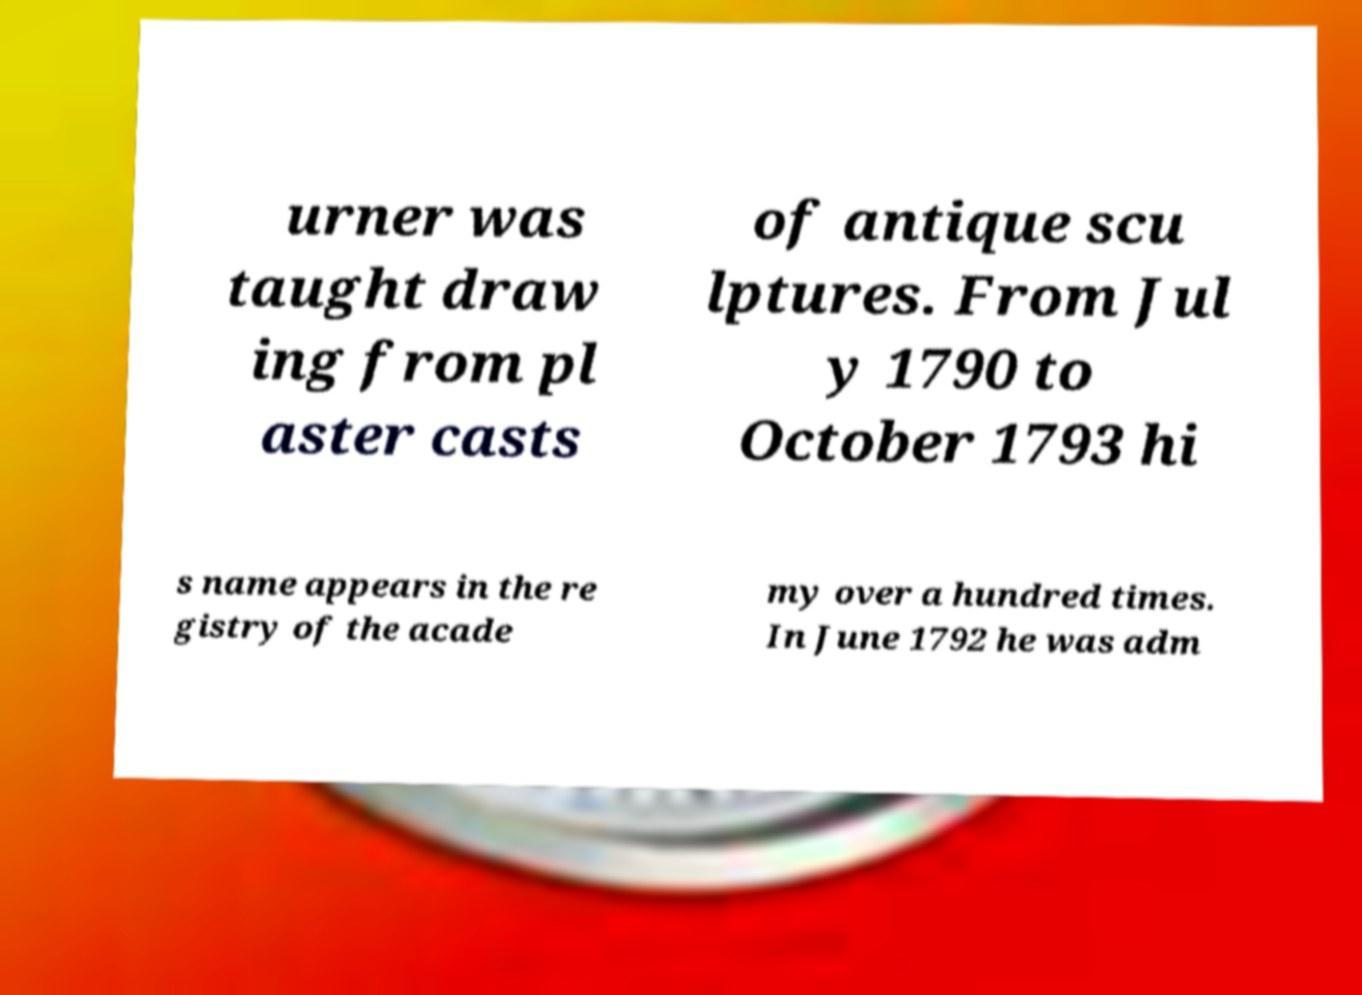There's text embedded in this image that I need extracted. Can you transcribe it verbatim? urner was taught draw ing from pl aster casts of antique scu lptures. From Jul y 1790 to October 1793 hi s name appears in the re gistry of the acade my over a hundred times. In June 1792 he was adm 